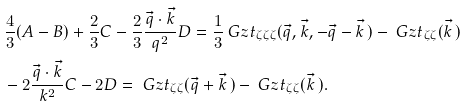Convert formula to latex. <formula><loc_0><loc_0><loc_500><loc_500>& \frac { 4 } { 3 } ( A - B ) + \frac { 2 } { 3 } C - \frac { 2 } { 3 } \frac { \vec { q } \cdot \vec { k } } { q ^ { 2 } } D = \frac { 1 } { 3 } \ G z t _ { \zeta \zeta \zeta } ( \vec { q } , \vec { k } , - \vec { q } - \vec { k } \, ) - \ G z t _ { \zeta \zeta } ( \vec { k } \, ) \\ & - 2 \frac { \vec { q } \cdot \vec { k } } { k ^ { 2 } } C - 2 D = \ G z t _ { \zeta \zeta } ( \vec { q } + \vec { k } \, ) - \ G z t _ { \zeta \zeta } ( \vec { k } \, ) .</formula> 